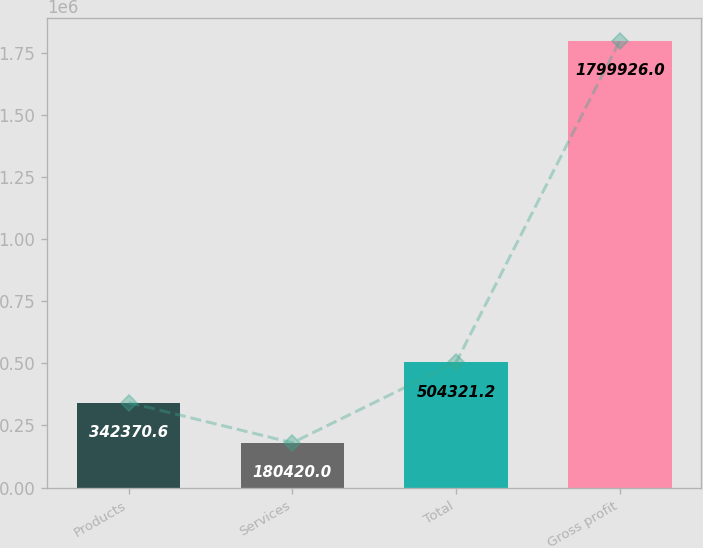Convert chart. <chart><loc_0><loc_0><loc_500><loc_500><bar_chart><fcel>Products<fcel>Services<fcel>Total<fcel>Gross profit<nl><fcel>342371<fcel>180420<fcel>504321<fcel>1.79993e+06<nl></chart> 